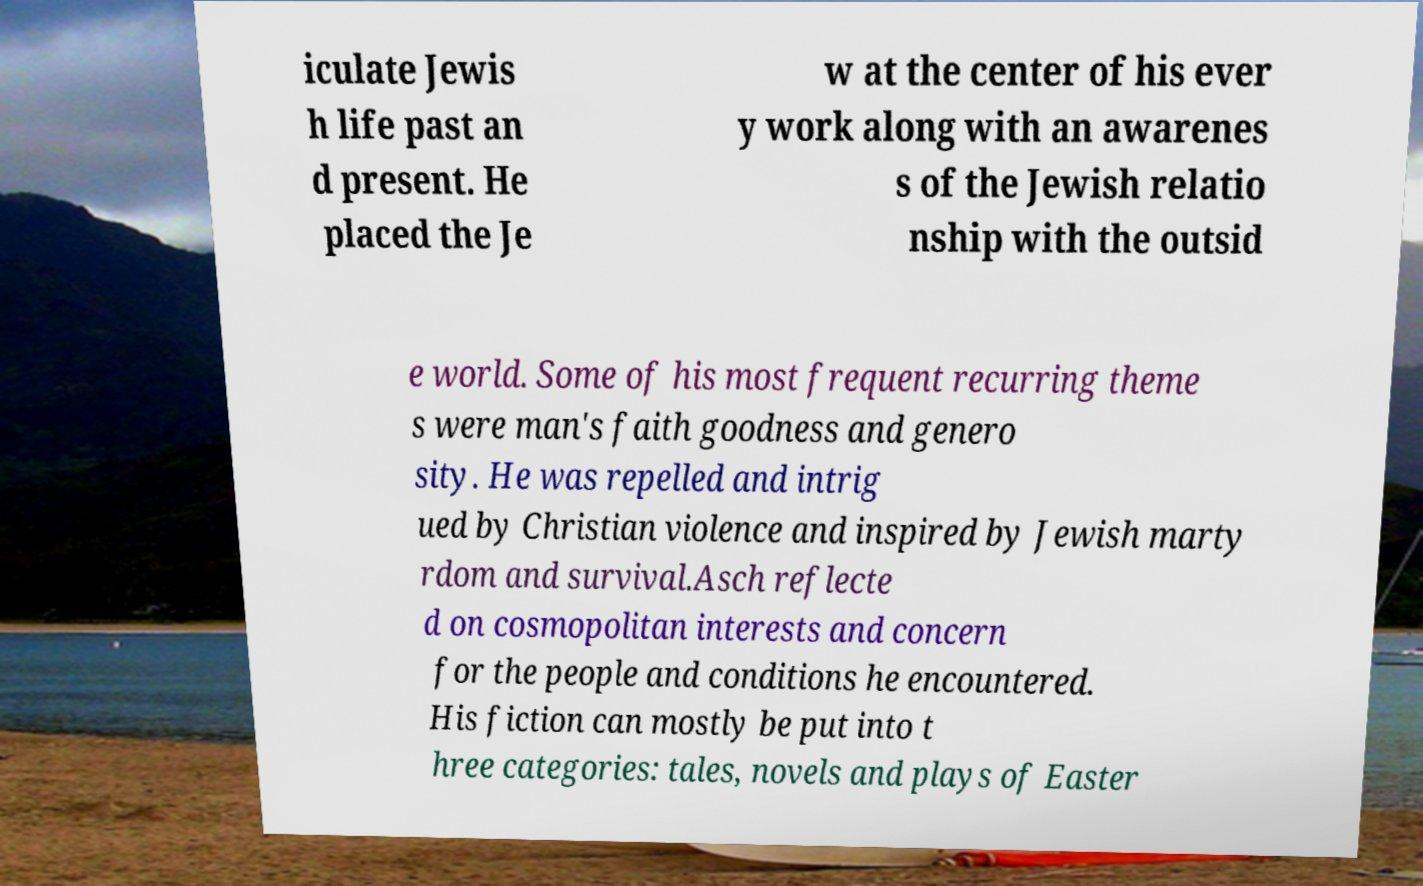For documentation purposes, I need the text within this image transcribed. Could you provide that? iculate Jewis h life past an d present. He placed the Je w at the center of his ever y work along with an awarenes s of the Jewish relatio nship with the outsid e world. Some of his most frequent recurring theme s were man's faith goodness and genero sity. He was repelled and intrig ued by Christian violence and inspired by Jewish marty rdom and survival.Asch reflecte d on cosmopolitan interests and concern for the people and conditions he encountered. His fiction can mostly be put into t hree categories: tales, novels and plays of Easter 